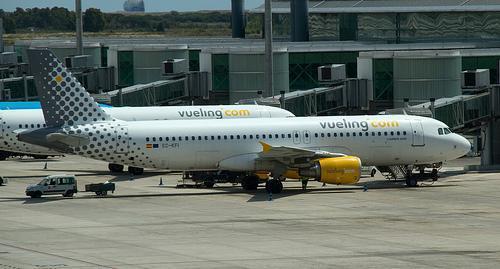How many planes are there?
Give a very brief answer. 2. 